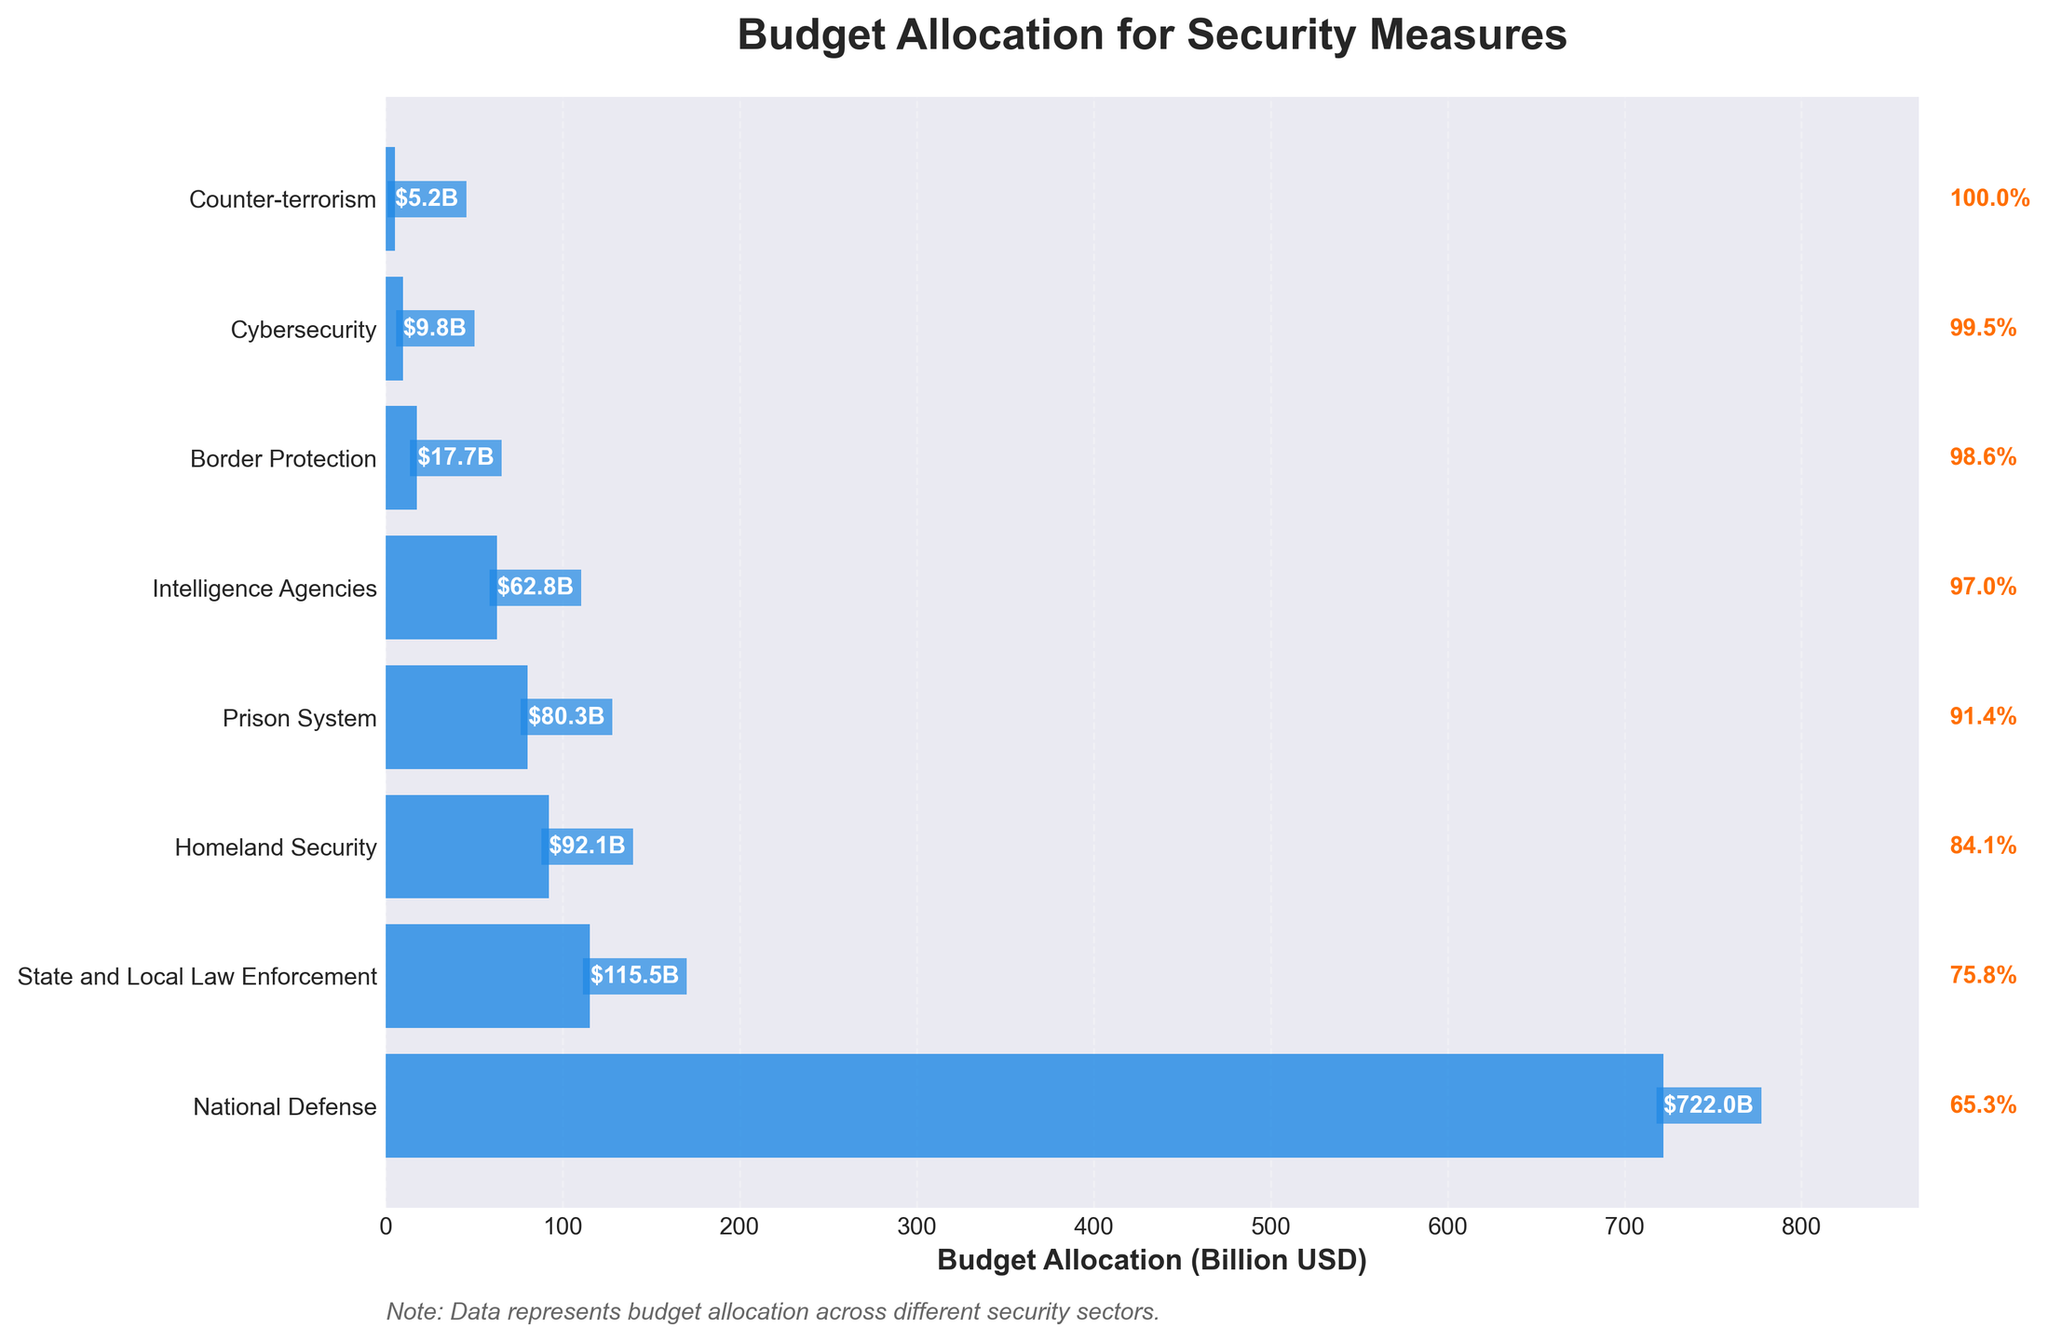How much is allocated for National Defense? The figure shows that the largest budget allocation is for National Defense. Looking at the budget value next to the bar for National Defense, we see it is $722 billion.
Answer: $722 billion What is the second highest budget allocation category? The figure shows bars arranged in descending order of budget allocation. The second bar from the top represents Homeland Security with a budget of $92.1 billion.
Answer: Homeland Security Which category has the smallest budget allocation? The figure shows bars in descending order of budget allocation. The last (bottom-most) bar represents Counter-terrorism with a budget of $5.2 billion.
Answer: Counter-terrorism How much more is allocated to State and Local Law Enforcement compared to Cybersecurity? We refer to the budget values for State and Local Law Enforcement ($115.5 billion) and Cybersecurity ($9.8 billion). The difference is $115.5 billion - $9.8 billion = $105.7 billion.
Answer: $105.7 billion What is the combined budget for Border Protection and Intelligence Agencies? The budget for Border Protection is $17.7 billion and for Intelligence Agencies is $62.8 billion. Adding these values gives $17.7 billion + $62.8 billion = $80.5 billion.
Answer: $80.5 billion How many categories have a budget allocation greater than $50 billion? We observe the budget values in the figure and identify the categories with values greater than $50 billion. They are National Defense, Homeland Security, State and Local Law Enforcement, Prison System, and Intelligence Agencies, totaling 5 categories.
Answer: 5 What is the percentage of the total budget allocated to National Defense? According to the figure, National Defense has a budget allocation of $722 billion. To find the percentage, we need the total budget of all categories (sum of all values) which is $722 + $92.1 + $115.5 + $17.7 + $9.8 + $5.2 + $80.3 + $62.8 = $1105.4 billion. Hence, the percentage is ($722 billion / $1105.4 billion) * 100 ≈ 65.3%.
Answer: 65.3% If we reallocated $10 billion from National Defense to Cybersecurity, what would the new budget allocations be? Currently, National Defense has $722 billion and Cybersecurity has $9.8 billion. Subtract $10 billion from National Defense, leaving it with $712 billion, and add $10 billion to Cybersecurity, giving it $19.8 billion.
Answer: $712 billion (National Defense), $19.8 billion (Cybersecurity) What is the difference in budget allocation between the Prison System and Intelligence Agencies? Referring to the budget values for the Prison System ($80.3 billion) and Intelligence Agencies ($62.8 billion), the difference is $80.3 billion - $62.8 billion = $17.5 billion.
Answer: $17.5 billion 